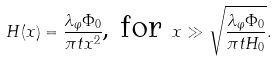<formula> <loc_0><loc_0><loc_500><loc_500>H ( x ) = \frac { \lambda _ { \varphi } \Phi _ { 0 } } { \pi t x ^ { 2 } } \text {, for } x \gg \sqrt { \frac { \lambda _ { \varphi } \Phi _ { 0 } } { \pi t H _ { 0 } } } .</formula> 